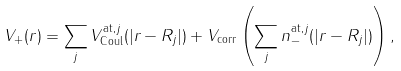<formula> <loc_0><loc_0><loc_500><loc_500>V _ { + } ( r ) = \sum _ { j } V _ { \text {Coul} } ^ { \text {at} , j } ( | r - R _ { j } | ) + V _ { \text {corr} } \left ( \sum _ { j } n _ { - } ^ { \text {at} , j } ( | r - R _ { j } | ) \right ) ,</formula> 